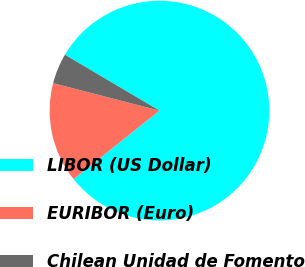Convert chart. <chart><loc_0><loc_0><loc_500><loc_500><pie_chart><fcel>LIBOR (US Dollar)<fcel>EURIBOR (Euro)<fcel>Chilean Unidad de Fomento<nl><fcel>80.79%<fcel>14.74%<fcel>4.47%<nl></chart> 